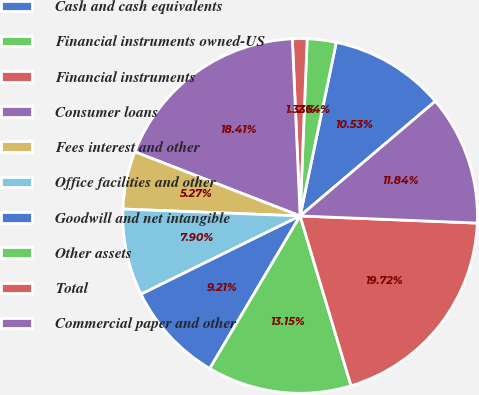Convert chart. <chart><loc_0><loc_0><loc_500><loc_500><pie_chart><fcel>Cash and cash equivalents<fcel>Financial instruments owned-US<fcel>Financial instruments<fcel>Consumer loans<fcel>Fees interest and other<fcel>Office facilities and other<fcel>Goodwill and net intangible<fcel>Other assets<fcel>Total<fcel>Commercial paper and other<nl><fcel>10.53%<fcel>2.64%<fcel>1.33%<fcel>18.41%<fcel>5.27%<fcel>7.9%<fcel>9.21%<fcel>13.15%<fcel>19.72%<fcel>11.84%<nl></chart> 